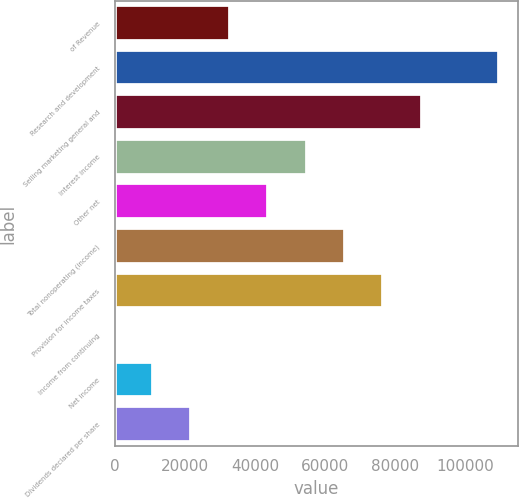Convert chart to OTSL. <chart><loc_0><loc_0><loc_500><loc_500><bar_chart><fcel>of Revenue<fcel>Research and development<fcel>Selling marketing general and<fcel>Interest income<fcel>Other net<fcel>Total nonoperating (income)<fcel>Provision for income taxes<fcel>Income from continuing<fcel>Net income<fcel>Dividends declared per share<nl><fcel>32834.5<fcel>109448<fcel>87558.4<fcel>54724.1<fcel>43779.3<fcel>65668.9<fcel>76613.6<fcel>0.18<fcel>10945<fcel>21889.7<nl></chart> 